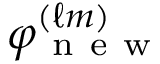<formula> <loc_0><loc_0><loc_500><loc_500>\varphi _ { n e w } ^ { ( \ell m ) }</formula> 